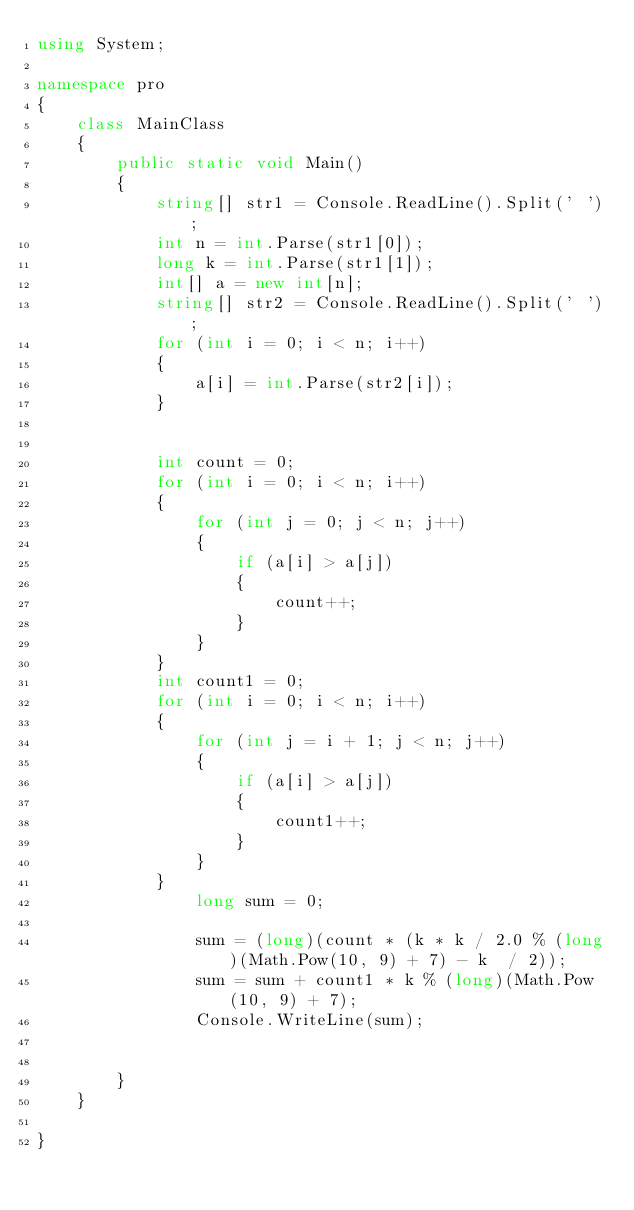Convert code to text. <code><loc_0><loc_0><loc_500><loc_500><_C#_>using System;

namespace pro
{
    class MainClass
    {
        public static void Main()
        {
            string[] str1 = Console.ReadLine().Split(' ');
            int n = int.Parse(str1[0]);
            long k = int.Parse(str1[1]);
            int[] a = new int[n];
            string[] str2 = Console.ReadLine().Split(' ');
            for (int i = 0; i < n; i++)
            {
                a[i] = int.Parse(str2[i]);
            }


            int count = 0;
            for (int i = 0; i < n; i++)
            {
                for (int j = 0; j < n; j++)
                {
                    if (a[i] > a[j])
                    {
                        count++;
                    }
                }
            }
            int count1 = 0;
            for (int i = 0; i < n; i++)
            {
                for (int j = i + 1; j < n; j++)
                {
                    if (a[i] > a[j])
                    {
                        count1++;
                    }
                }
            }
                long sum = 0;

                sum = (long)(count * (k * k / 2.0 % (long)(Math.Pow(10, 9) + 7) - k  / 2));
                sum = sum + count1 * k % (long)(Math.Pow(10, 9) + 7);
                Console.WriteLine(sum);
            

        }
    }

}</code> 